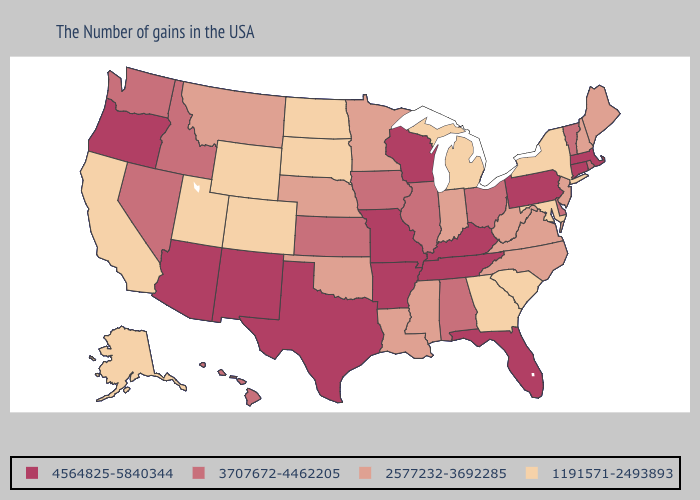Among the states that border Massachusetts , does Vermont have the highest value?
Quick response, please. No. Does Nebraska have a higher value than California?
Give a very brief answer. Yes. Among the states that border New York , does New Jersey have the lowest value?
Quick response, please. Yes. How many symbols are there in the legend?
Answer briefly. 4. What is the value of Texas?
Keep it brief. 4564825-5840344. Does Delaware have a higher value than North Carolina?
Write a very short answer. Yes. Name the states that have a value in the range 4564825-5840344?
Keep it brief. Massachusetts, Connecticut, Pennsylvania, Florida, Kentucky, Tennessee, Wisconsin, Missouri, Arkansas, Texas, New Mexico, Arizona, Oregon. What is the value of New York?
Be succinct. 1191571-2493893. Which states hav the highest value in the West?
Short answer required. New Mexico, Arizona, Oregon. What is the value of New Mexico?
Answer briefly. 4564825-5840344. Does Massachusetts have the highest value in the Northeast?
Be succinct. Yes. What is the highest value in the Northeast ?
Concise answer only. 4564825-5840344. Does Connecticut have the highest value in the USA?
Answer briefly. Yes. What is the lowest value in the South?
Concise answer only. 1191571-2493893. Name the states that have a value in the range 1191571-2493893?
Answer briefly. New York, Maryland, South Carolina, Georgia, Michigan, South Dakota, North Dakota, Wyoming, Colorado, Utah, California, Alaska. 